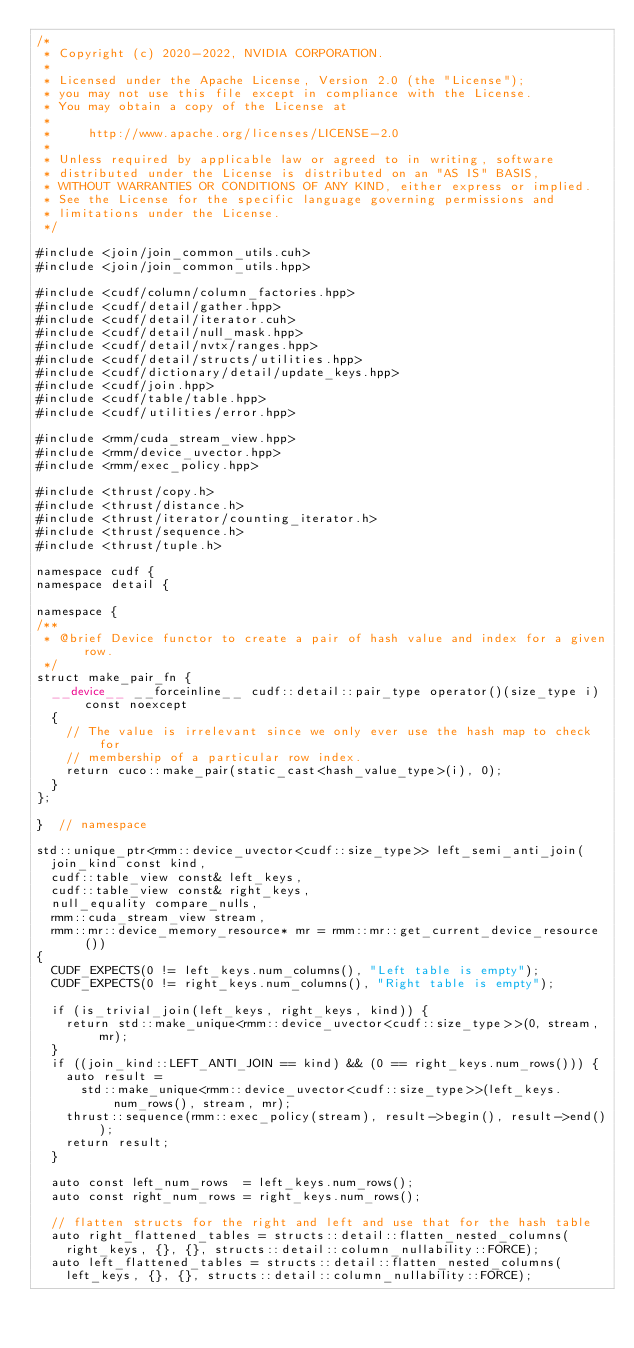<code> <loc_0><loc_0><loc_500><loc_500><_Cuda_>/*
 * Copyright (c) 2020-2022, NVIDIA CORPORATION.
 *
 * Licensed under the Apache License, Version 2.0 (the "License");
 * you may not use this file except in compliance with the License.
 * You may obtain a copy of the License at
 *
 *     http://www.apache.org/licenses/LICENSE-2.0
 *
 * Unless required by applicable law or agreed to in writing, software
 * distributed under the License is distributed on an "AS IS" BASIS,
 * WITHOUT WARRANTIES OR CONDITIONS OF ANY KIND, either express or implied.
 * See the License for the specific language governing permissions and
 * limitations under the License.
 */

#include <join/join_common_utils.cuh>
#include <join/join_common_utils.hpp>

#include <cudf/column/column_factories.hpp>
#include <cudf/detail/gather.hpp>
#include <cudf/detail/iterator.cuh>
#include <cudf/detail/null_mask.hpp>
#include <cudf/detail/nvtx/ranges.hpp>
#include <cudf/detail/structs/utilities.hpp>
#include <cudf/dictionary/detail/update_keys.hpp>
#include <cudf/join.hpp>
#include <cudf/table/table.hpp>
#include <cudf/utilities/error.hpp>

#include <rmm/cuda_stream_view.hpp>
#include <rmm/device_uvector.hpp>
#include <rmm/exec_policy.hpp>

#include <thrust/copy.h>
#include <thrust/distance.h>
#include <thrust/iterator/counting_iterator.h>
#include <thrust/sequence.h>
#include <thrust/tuple.h>

namespace cudf {
namespace detail {

namespace {
/**
 * @brief Device functor to create a pair of hash value and index for a given row.
 */
struct make_pair_fn {
  __device__ __forceinline__ cudf::detail::pair_type operator()(size_type i) const noexcept
  {
    // The value is irrelevant since we only ever use the hash map to check for
    // membership of a particular row index.
    return cuco::make_pair(static_cast<hash_value_type>(i), 0);
  }
};

}  // namespace

std::unique_ptr<rmm::device_uvector<cudf::size_type>> left_semi_anti_join(
  join_kind const kind,
  cudf::table_view const& left_keys,
  cudf::table_view const& right_keys,
  null_equality compare_nulls,
  rmm::cuda_stream_view stream,
  rmm::mr::device_memory_resource* mr = rmm::mr::get_current_device_resource())
{
  CUDF_EXPECTS(0 != left_keys.num_columns(), "Left table is empty");
  CUDF_EXPECTS(0 != right_keys.num_columns(), "Right table is empty");

  if (is_trivial_join(left_keys, right_keys, kind)) {
    return std::make_unique<rmm::device_uvector<cudf::size_type>>(0, stream, mr);
  }
  if ((join_kind::LEFT_ANTI_JOIN == kind) && (0 == right_keys.num_rows())) {
    auto result =
      std::make_unique<rmm::device_uvector<cudf::size_type>>(left_keys.num_rows(), stream, mr);
    thrust::sequence(rmm::exec_policy(stream), result->begin(), result->end());
    return result;
  }

  auto const left_num_rows  = left_keys.num_rows();
  auto const right_num_rows = right_keys.num_rows();

  // flatten structs for the right and left and use that for the hash table
  auto right_flattened_tables = structs::detail::flatten_nested_columns(
    right_keys, {}, {}, structs::detail::column_nullability::FORCE);
  auto left_flattened_tables = structs::detail::flatten_nested_columns(
    left_keys, {}, {}, structs::detail::column_nullability::FORCE);
</code> 